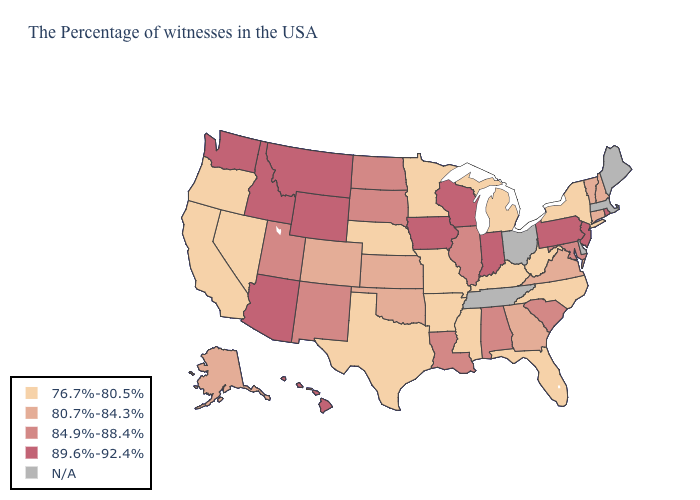What is the value of Alabama?
Write a very short answer. 84.9%-88.4%. What is the value of Tennessee?
Give a very brief answer. N/A. Which states have the lowest value in the USA?
Keep it brief. New York, North Carolina, West Virginia, Florida, Michigan, Kentucky, Mississippi, Missouri, Arkansas, Minnesota, Nebraska, Texas, Nevada, California, Oregon. Which states hav the highest value in the MidWest?
Write a very short answer. Indiana, Wisconsin, Iowa. Which states have the lowest value in the USA?
Concise answer only. New York, North Carolina, West Virginia, Florida, Michigan, Kentucky, Mississippi, Missouri, Arkansas, Minnesota, Nebraska, Texas, Nevada, California, Oregon. What is the highest value in the USA?
Keep it brief. 89.6%-92.4%. What is the highest value in states that border Kentucky?
Concise answer only. 89.6%-92.4%. Among the states that border Ohio , which have the highest value?
Give a very brief answer. Pennsylvania, Indiana. Among the states that border Louisiana , which have the highest value?
Short answer required. Mississippi, Arkansas, Texas. Does North Carolina have the highest value in the South?
Concise answer only. No. Name the states that have a value in the range N/A?
Keep it brief. Maine, Massachusetts, Delaware, Ohio, Tennessee. How many symbols are there in the legend?
Be succinct. 5. Name the states that have a value in the range 84.9%-88.4%?
Short answer required. Maryland, South Carolina, Alabama, Illinois, Louisiana, South Dakota, North Dakota, New Mexico, Utah. 